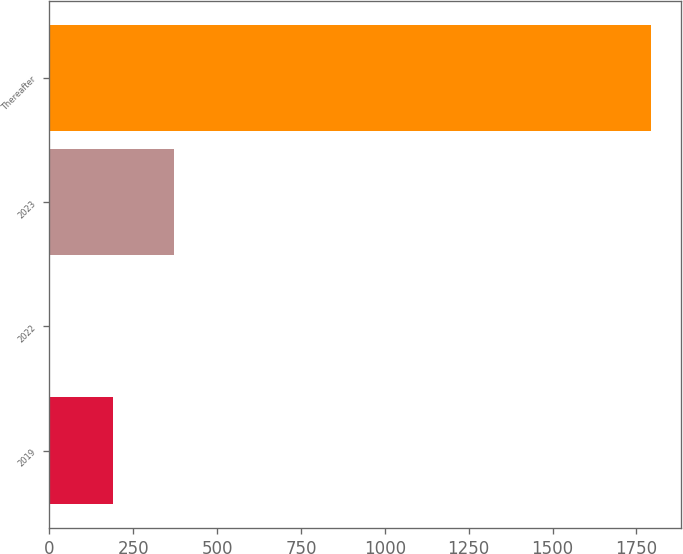Convert chart. <chart><loc_0><loc_0><loc_500><loc_500><bar_chart><fcel>2019<fcel>2022<fcel>2023<fcel>Thereafter<nl><fcel>188.5<fcel>0.4<fcel>370.8<fcel>1794.3<nl></chart> 